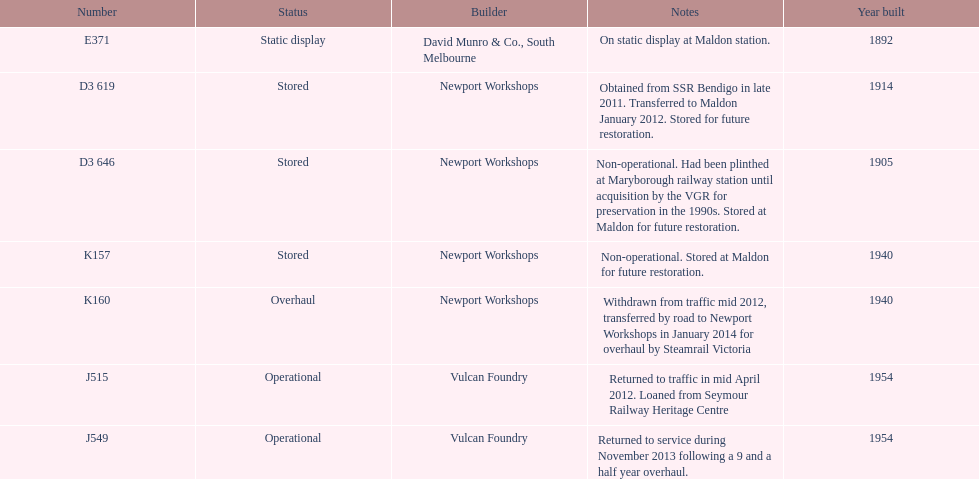How many of the locomotives were built before 1940? 3. 